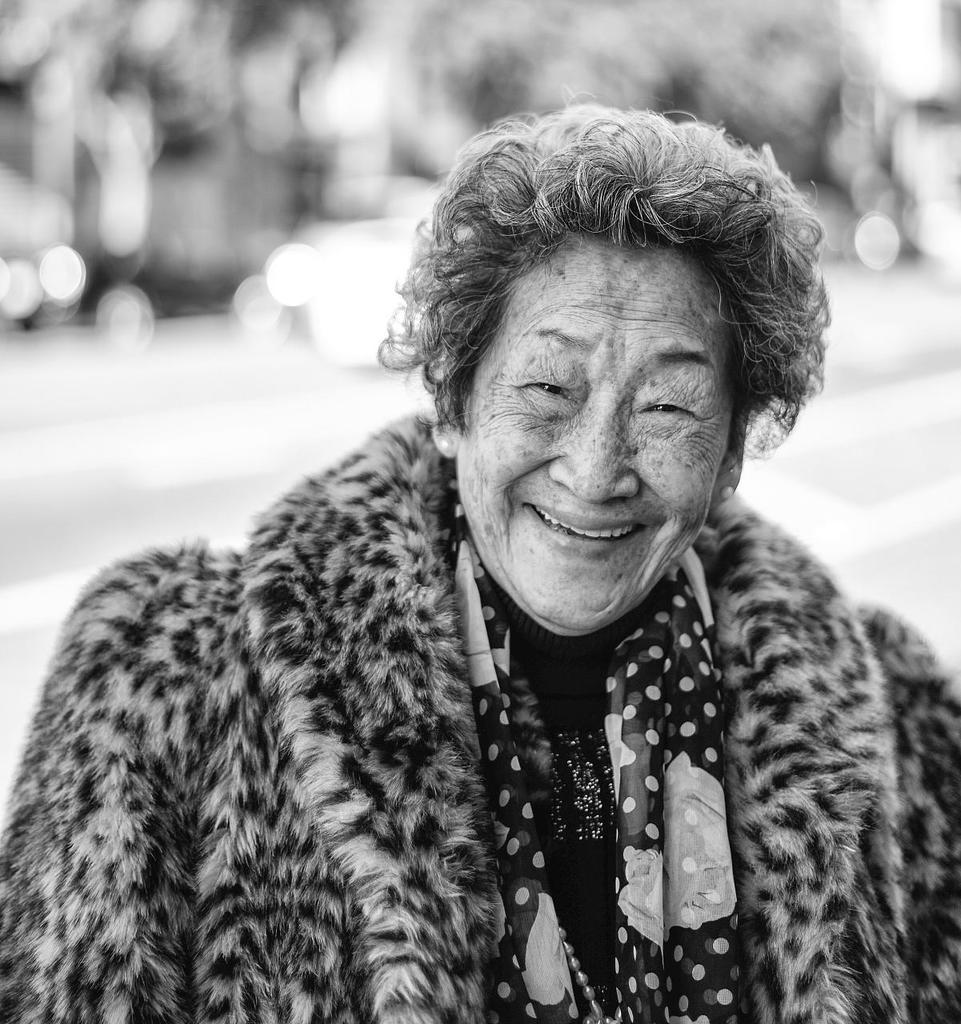What is the color scheme of the image? The image is black and white. Who is present in the image? There is a woman in the image. What is the woman wearing? The woman is wearing a sweater. Can you describe the background of the image? The background of the image is blurred. What type of soda is the woman holding in the image? There is no soda present in the image; it only features a woman wearing a sweater with a blurred background. What is your opinion on the woman's choice of sweater in the image? As an AI, I do not have personal opinions, but the woman is indeed wearing a sweater in the image. 